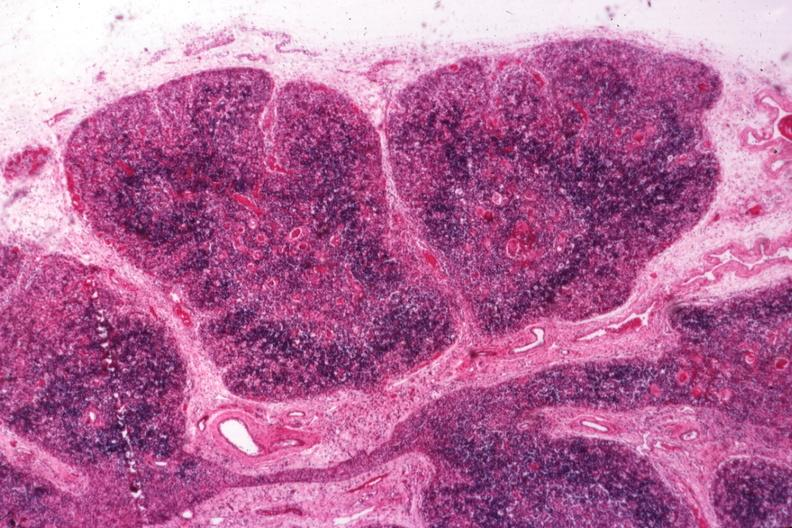s subdiaphragmatic abscess present?
Answer the question using a single word or phrase. No 